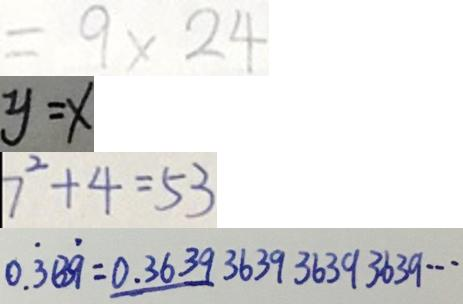<formula> <loc_0><loc_0><loc_500><loc_500>= 9 \times 2 4 
 y = x 
 7 ^ { 2 } + 4 = 5 3 
 0 . \dot { 3 } 3 \dot { 9 } = 0 . 3 6 3 9 3 6 3 9 3 6 3 9 3 6 3 9 \cdots</formula> 